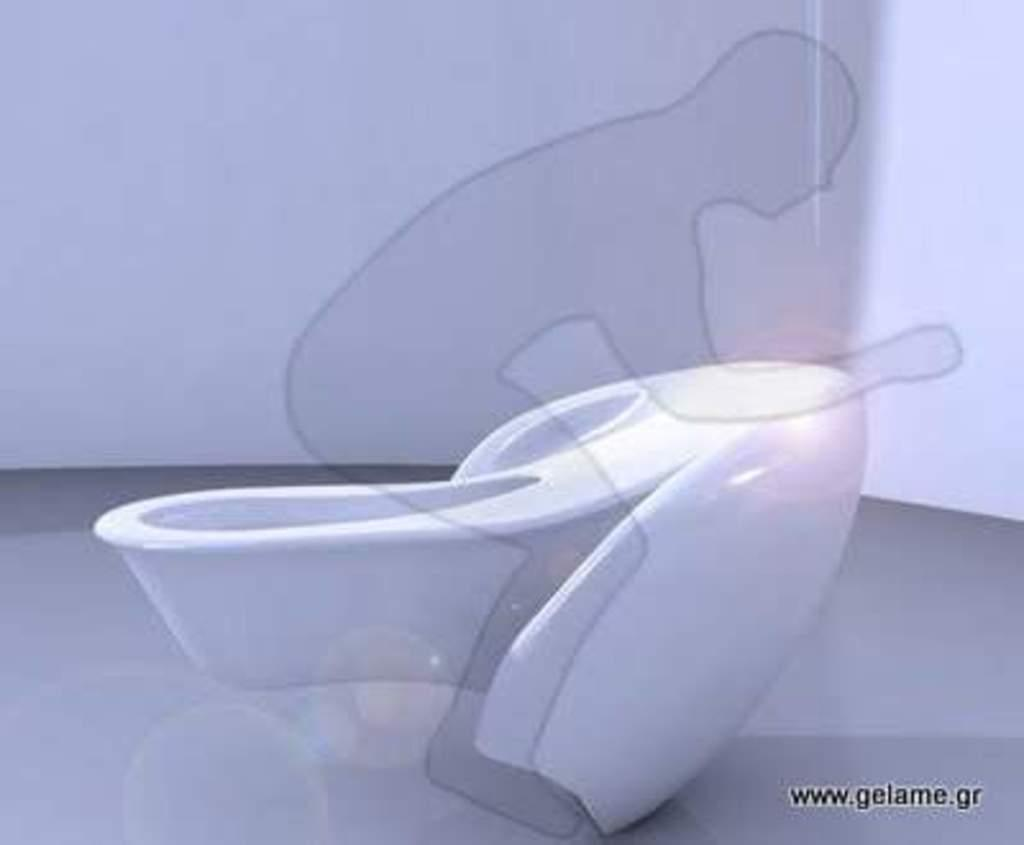What is the main object in the image? There is a toilet in the image. What can be seen behind the toilet? There is a wall in the background of the image. Are there any drawings or illustrations in the image? Yes, there is a drawing of a person in the image. Where is the text located in the image? The text is written in the right bottom corner of the image. Can you see a truck driving through a river in the image? No, there is no truck or river present in the image. 